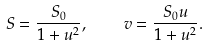Convert formula to latex. <formula><loc_0><loc_0><loc_500><loc_500>S = \frac { S _ { 0 } } { 1 + u ^ { 2 } } , \quad v = \frac { S _ { 0 } u } { 1 + u ^ { 2 } } .</formula> 